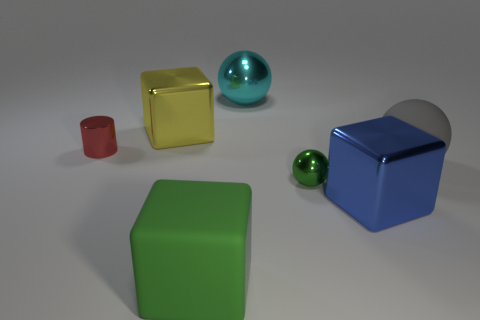Are there fewer green shiny balls behind the tiny metallic sphere than big yellow shiny cubes that are right of the tiny cylinder?
Ensure brevity in your answer.  Yes. There is a big matte object that is the same shape as the blue metal thing; what is its color?
Provide a short and direct response. Green. The cylinder has what size?
Your response must be concise. Small. Does the small sphere have the same color as the matte block?
Keep it short and to the point. Yes. Is there any other thing of the same color as the big matte block?
Provide a short and direct response. Yes. Does the tiny green object have the same material as the big green block?
Your answer should be compact. No. Does the tiny green shiny object have the same shape as the green rubber thing?
Ensure brevity in your answer.  No. Do the small metal ball and the large matte cube that is in front of the small metal cylinder have the same color?
Provide a succinct answer. Yes. There is a small metal thing that is to the right of the cyan object; is it the same color as the rubber cube?
Your response must be concise. Yes. There is a object that is behind the small cylinder and right of the rubber cube; what material is it?
Make the answer very short. Metal. 